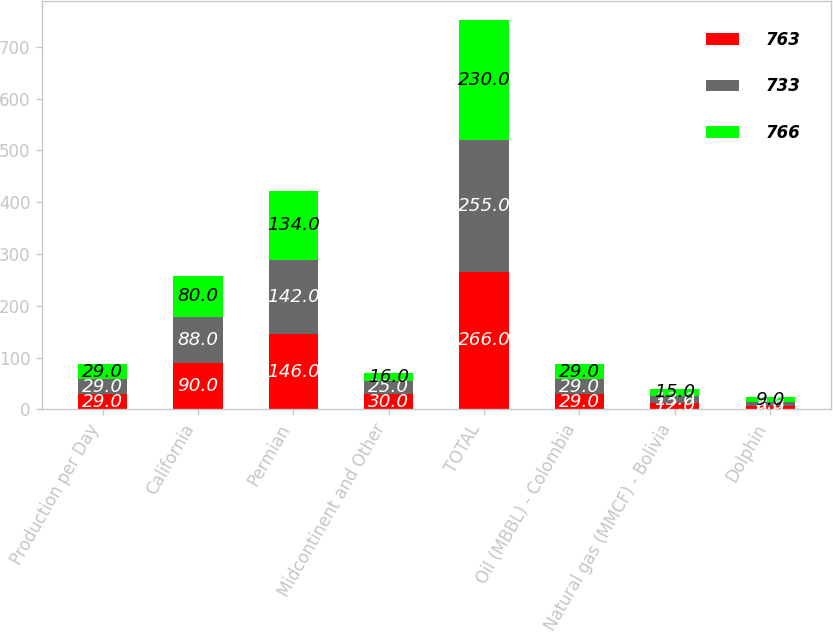Convert chart. <chart><loc_0><loc_0><loc_500><loc_500><stacked_bar_chart><ecel><fcel>Production per Day<fcel>California<fcel>Permian<fcel>Midcontinent and Other<fcel>TOTAL<fcel>Oil (MBBL) - Colombia<fcel>Natural gas (MMCF) - Bolivia<fcel>Dolphin<nl><fcel>763<fcel>29<fcel>90<fcel>146<fcel>30<fcel>266<fcel>29<fcel>12<fcel>6<nl><fcel>733<fcel>29<fcel>88<fcel>142<fcel>25<fcel>255<fcel>29<fcel>13<fcel>8<nl><fcel>766<fcel>29<fcel>80<fcel>134<fcel>16<fcel>230<fcel>29<fcel>15<fcel>9<nl></chart> 